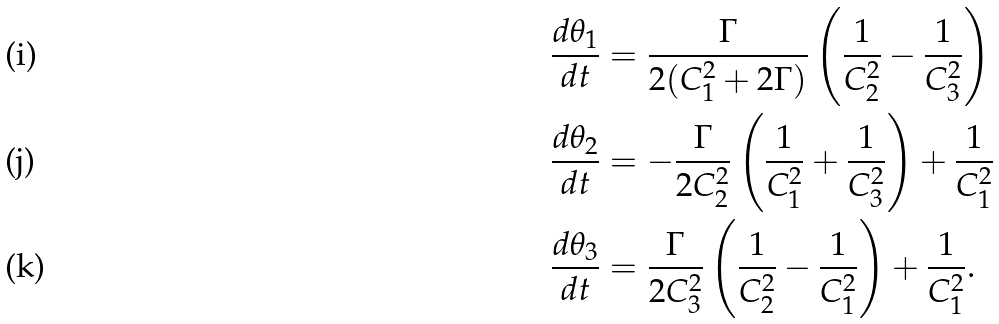<formula> <loc_0><loc_0><loc_500><loc_500>\frac { d \theta _ { 1 } } { d t } & = \frac { \Gamma } { 2 ( C _ { 1 } ^ { 2 } + 2 \Gamma ) } \left ( \frac { 1 } { C _ { 2 } ^ { 2 } } - \frac { 1 } { C _ { 3 } ^ { 2 } } \right ) \\ \frac { d \theta _ { 2 } } { d t } & = - \frac { \Gamma } { 2 C _ { 2 } ^ { 2 } } \left ( \frac { 1 } { C _ { 1 } ^ { 2 } } + \frac { 1 } { C _ { 3 } ^ { 2 } } \right ) + \frac { 1 } { C _ { 1 } ^ { 2 } } \\ \frac { d \theta _ { 3 } } { d t } & = \frac { \Gamma } { 2 C _ { 3 } ^ { 2 } } \left ( \frac { 1 } { C _ { 2 } ^ { 2 } } - \frac { 1 } { C _ { 1 } ^ { 2 } } \right ) + \frac { 1 } { C _ { 1 } ^ { 2 } } .</formula> 